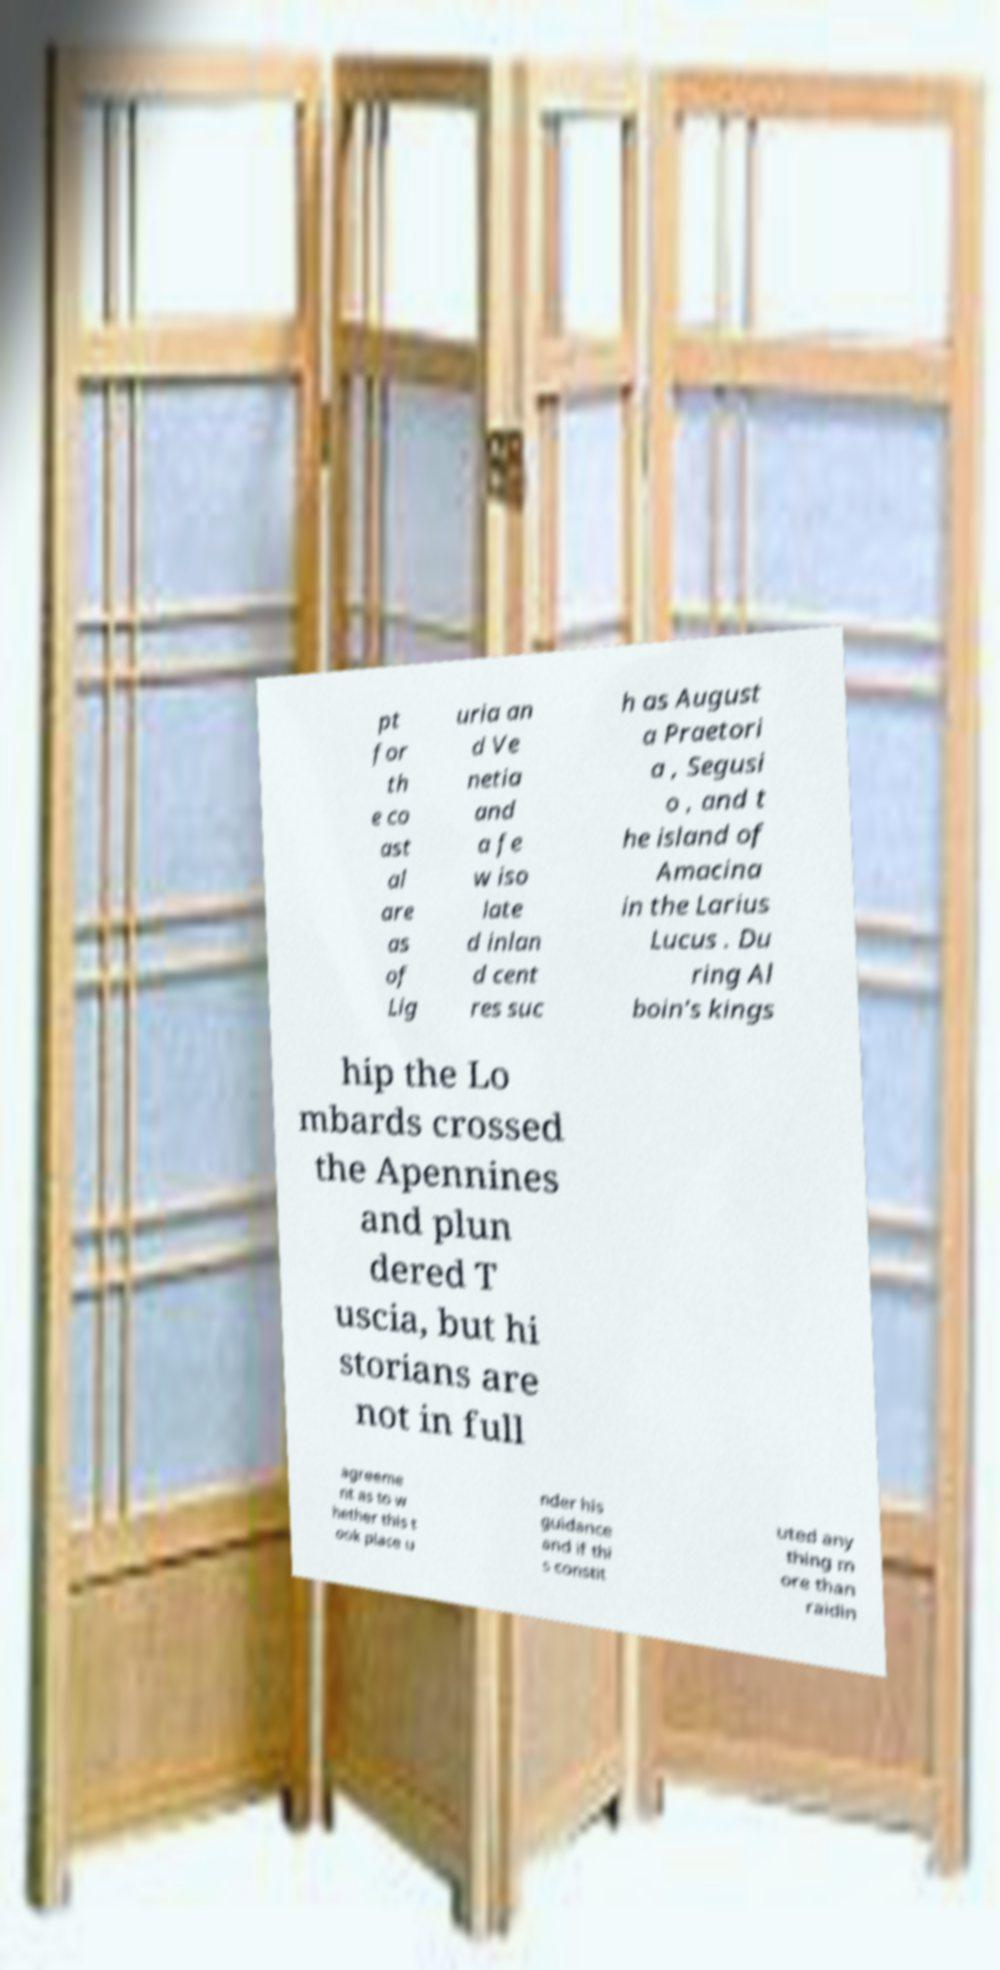Could you extract and type out the text from this image? pt for th e co ast al are as of Lig uria an d Ve netia and a fe w iso late d inlan d cent res suc h as August a Praetori a , Segusi o , and t he island of Amacina in the Larius Lucus . Du ring Al boin's kings hip the Lo mbards crossed the Apennines and plun dered T uscia, but hi storians are not in full agreeme nt as to w hether this t ook place u nder his guidance and if thi s constit uted any thing m ore than raidin 